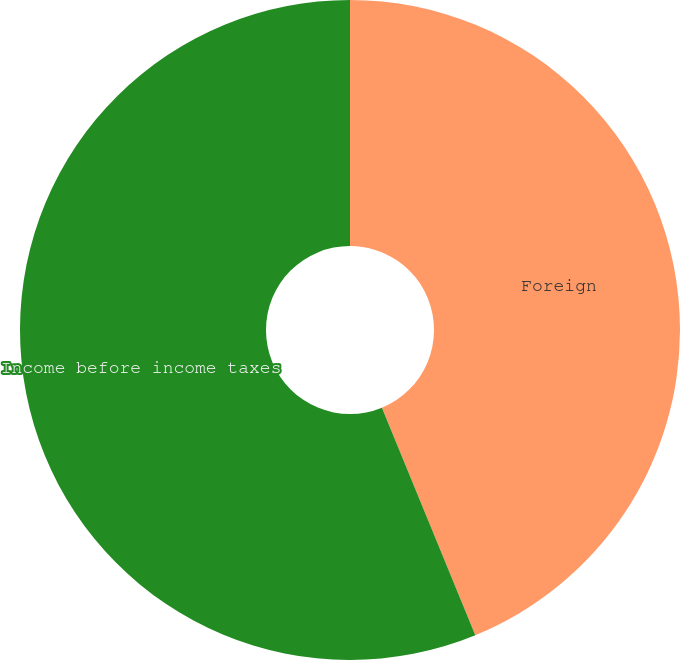<chart> <loc_0><loc_0><loc_500><loc_500><pie_chart><fcel>Foreign<fcel>Income before income taxes<nl><fcel>43.8%<fcel>56.2%<nl></chart> 